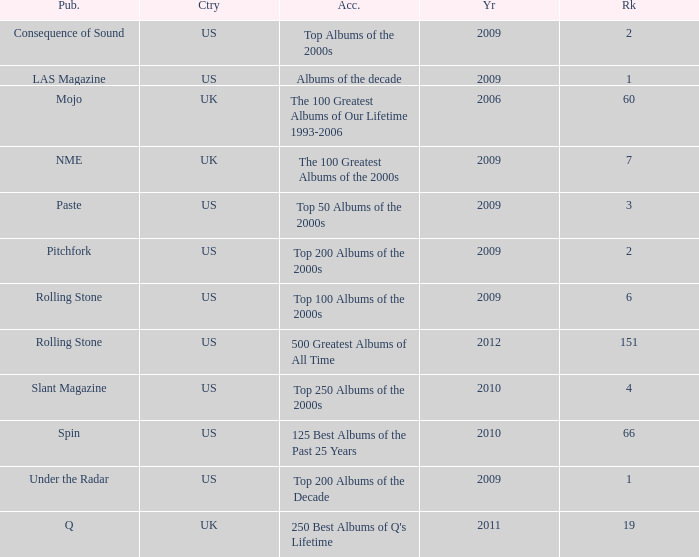What country had a paste publication in 2009? US. 